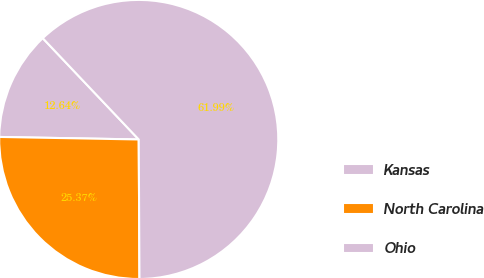<chart> <loc_0><loc_0><loc_500><loc_500><pie_chart><fcel>Kansas<fcel>North Carolina<fcel>Ohio<nl><fcel>12.64%<fcel>25.37%<fcel>61.99%<nl></chart> 